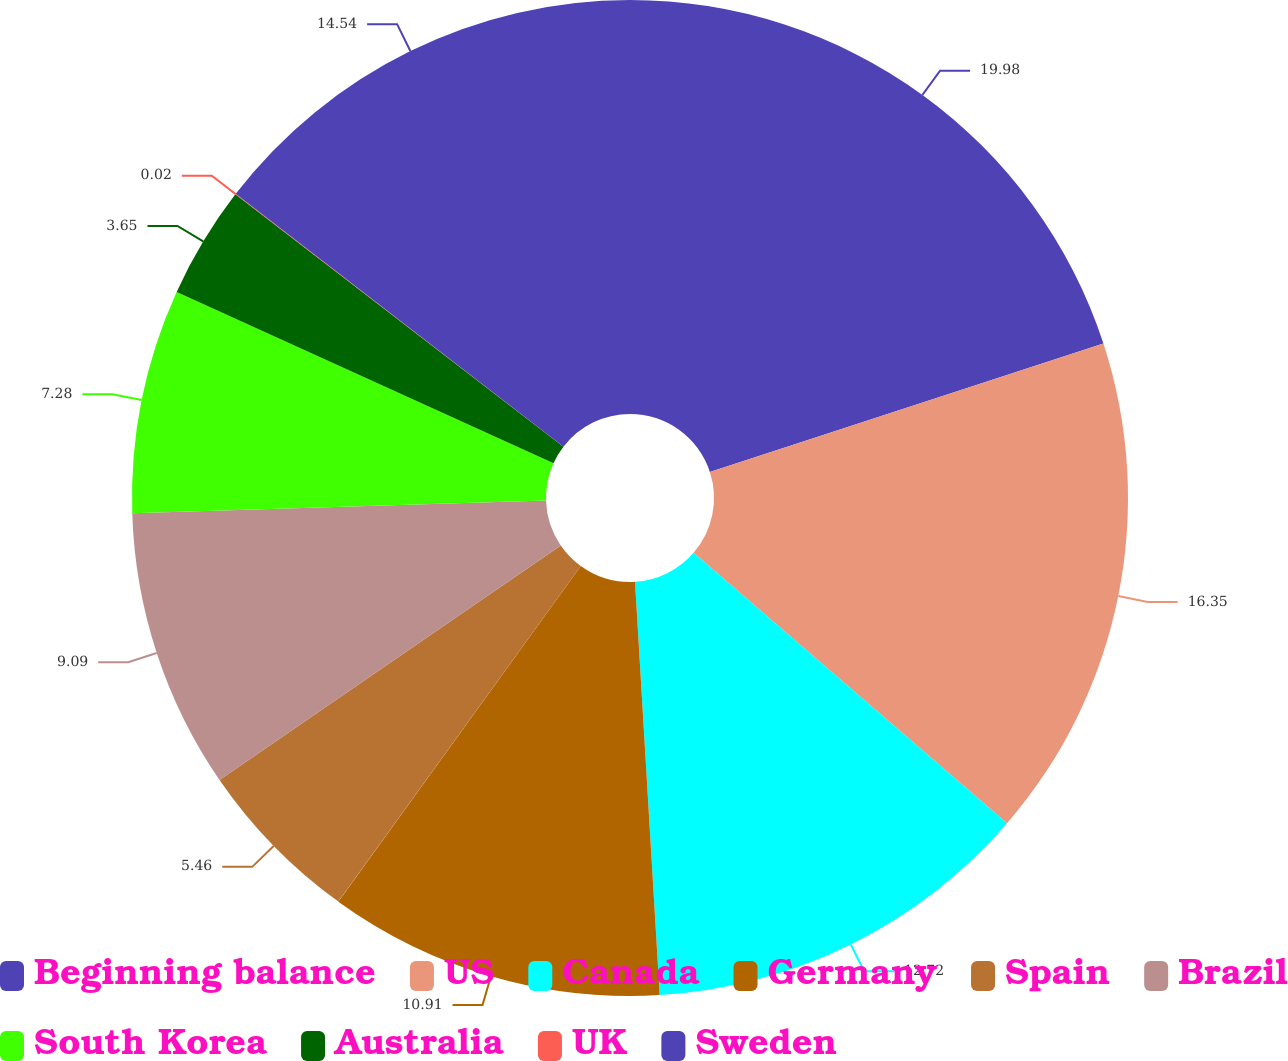Convert chart to OTSL. <chart><loc_0><loc_0><loc_500><loc_500><pie_chart><fcel>Beginning balance<fcel>US<fcel>Canada<fcel>Germany<fcel>Spain<fcel>Brazil<fcel>South Korea<fcel>Australia<fcel>UK<fcel>Sweden<nl><fcel>19.98%<fcel>16.35%<fcel>12.72%<fcel>10.91%<fcel>5.46%<fcel>9.09%<fcel>7.28%<fcel>3.65%<fcel>0.02%<fcel>14.54%<nl></chart> 